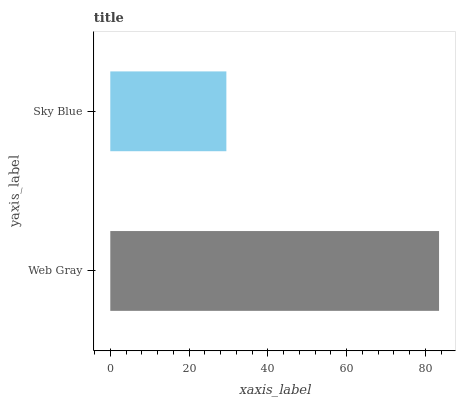Is Sky Blue the minimum?
Answer yes or no. Yes. Is Web Gray the maximum?
Answer yes or no. Yes. Is Sky Blue the maximum?
Answer yes or no. No. Is Web Gray greater than Sky Blue?
Answer yes or no. Yes. Is Sky Blue less than Web Gray?
Answer yes or no. Yes. Is Sky Blue greater than Web Gray?
Answer yes or no. No. Is Web Gray less than Sky Blue?
Answer yes or no. No. Is Web Gray the high median?
Answer yes or no. Yes. Is Sky Blue the low median?
Answer yes or no. Yes. Is Sky Blue the high median?
Answer yes or no. No. Is Web Gray the low median?
Answer yes or no. No. 